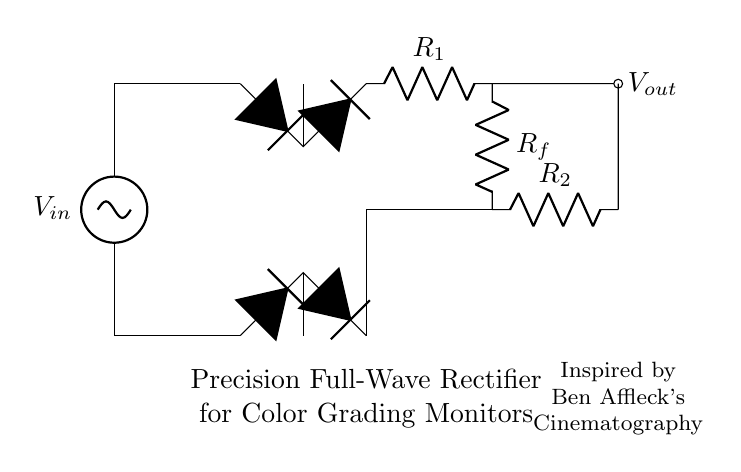What is the input voltage? The input voltage, represented as \(V_{in}\), is shown at the top of the circuit. This is where the AC signal enters the rectifier.
Answer: \(V_{in}\) How many diodes are in the bridge rectifier? The bridge rectifier section of the circuit has four diodes, represented as \(D*\) in the diagram. This is characteristic of a full-wave rectifier setup.
Answer: 4 What type of circuit is this? The overall circuit is a precision full-wave rectifier, which is specifically designed for accurate DC conversion of AC signals. This is indicated by the label in the diagram.
Answer: Precision full-wave rectifier What does \(R_f\) represent in the circuit? \(R_f\) indicates the feedback resistor in the rectifier configuration, which plays a critical role in determining the gain and stability of the operational amplifier used in the precision rectification.
Answer: Feedback resistor Which component provides the output voltage? The output voltage, labeled \(V_{out}\), is derived from the node after the resistor \(R_1\) and before the feedback network, indicating where the precise DC voltage is measured.
Answer: \(V_{out}\) How does the operational amplifier affect rectification? The operational amplifier, connected to the feedback loop, allows for precision rectification by minimizing the voltage drop across diodes, ensuring that the entire AC waveform is utilized for the output.
Answer: Minimizes diode voltage drop What is the purpose of labeling the circuit with Ben Affleck's cinematography? The label referencing Ben Affleck's cinematography serves as an inspiration for the design’s aesthetic, linking art and technology in the context of calibrating color grading monitors during film production.
Answer: Inspirational reference 